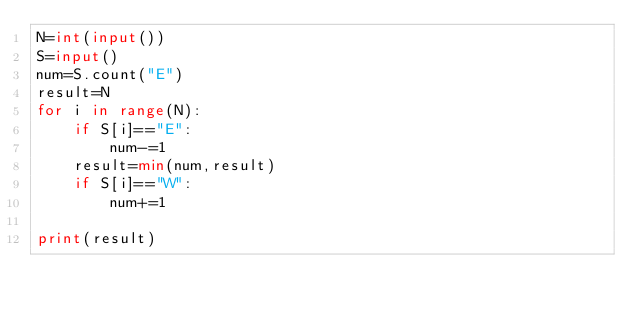<code> <loc_0><loc_0><loc_500><loc_500><_Python_>N=int(input())
S=input()
num=S.count("E")
result=N
for i in range(N):
    if S[i]=="E":
        num-=1
    result=min(num,result)
    if S[i]=="W":
        num+=1

print(result)
</code> 